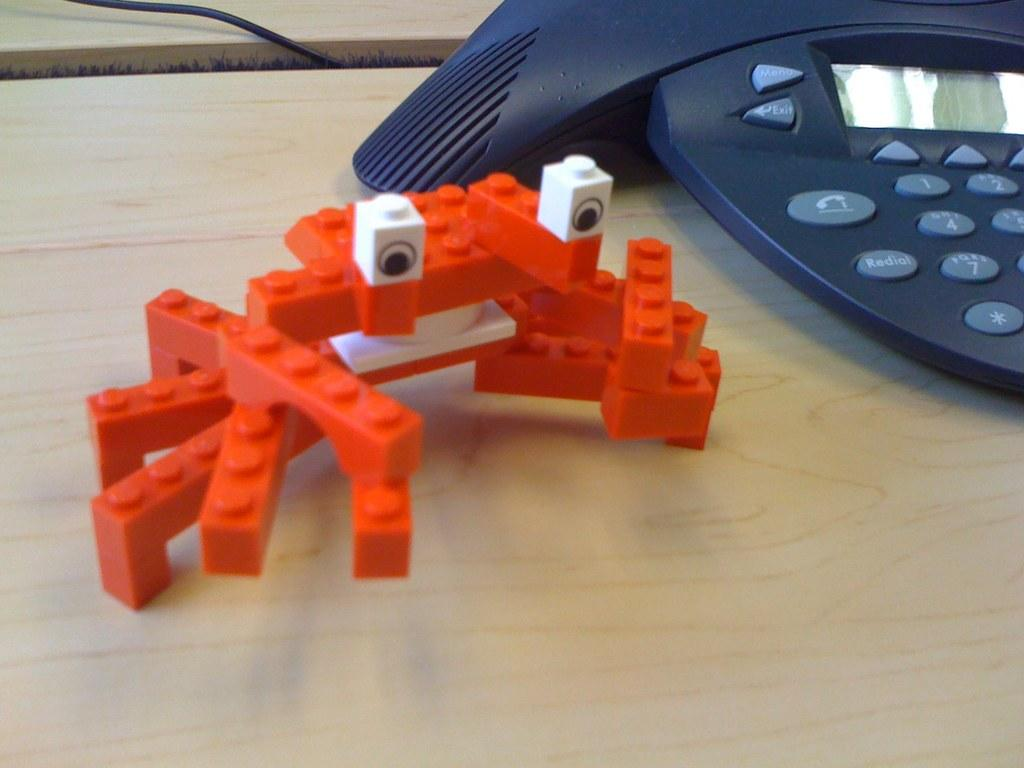<image>
Relay a brief, clear account of the picture shown. The blue phone next to the Lego crab has a redial button. 